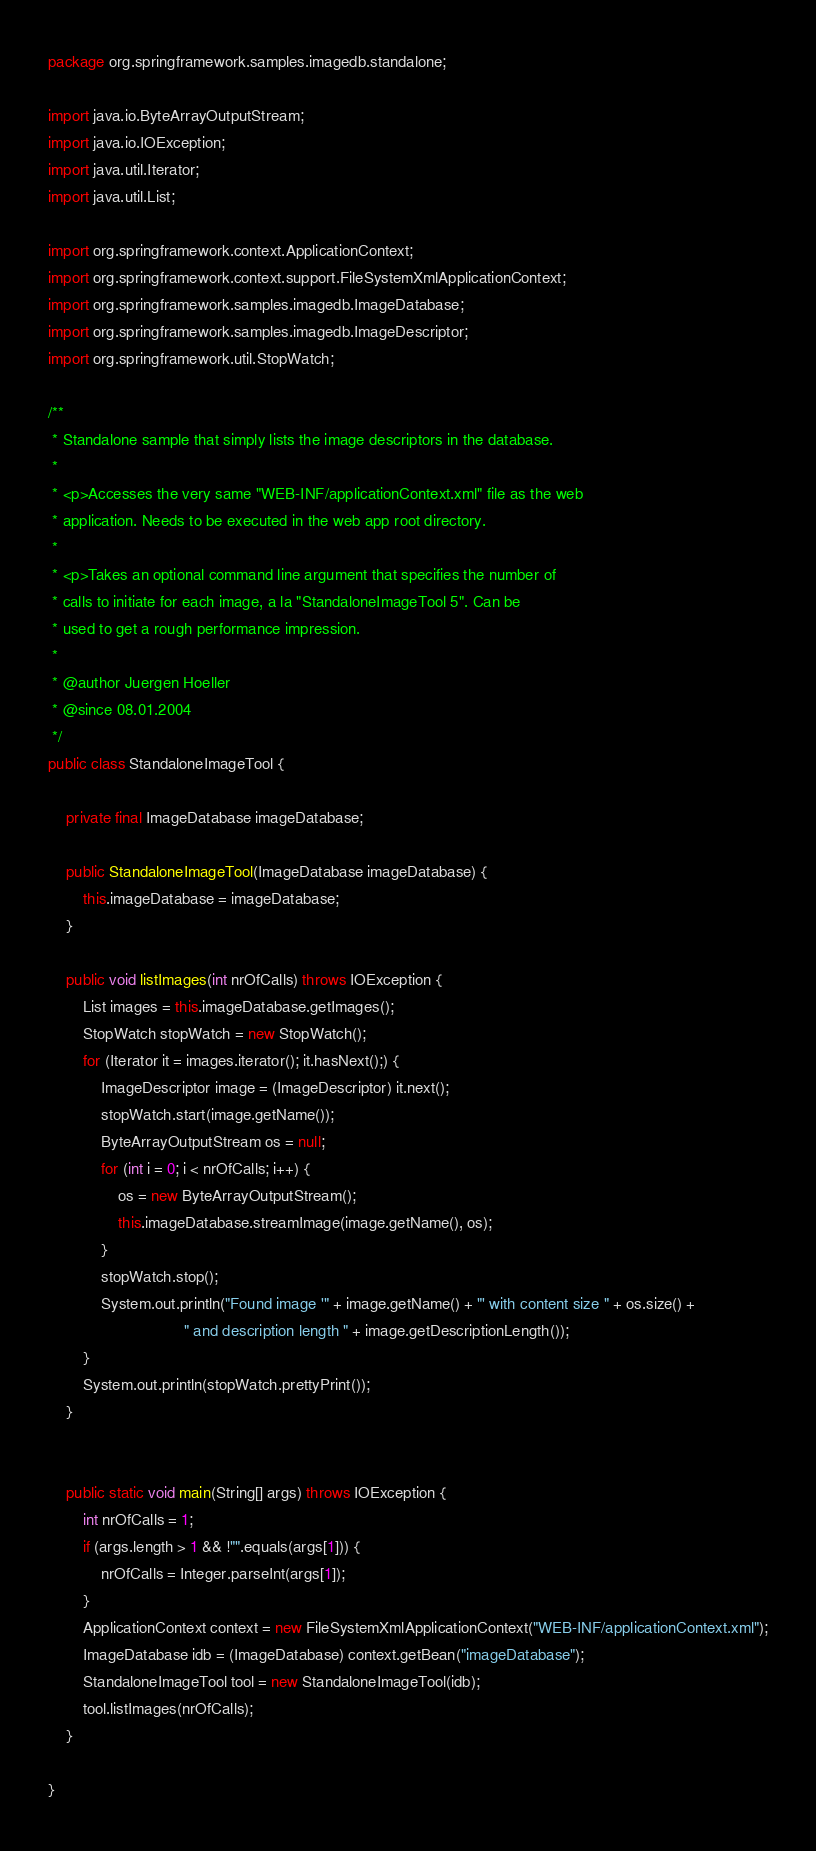<code> <loc_0><loc_0><loc_500><loc_500><_Java_>package org.springframework.samples.imagedb.standalone;

import java.io.ByteArrayOutputStream;
import java.io.IOException;
import java.util.Iterator;
import java.util.List;

import org.springframework.context.ApplicationContext;
import org.springframework.context.support.FileSystemXmlApplicationContext;
import org.springframework.samples.imagedb.ImageDatabase;
import org.springframework.samples.imagedb.ImageDescriptor;
import org.springframework.util.StopWatch;

/**
 * Standalone sample that simply lists the image descriptors in the database.
 *
 * <p>Accesses the very same "WEB-INF/applicationContext.xml" file as the web
 * application. Needs to be executed in the web app root directory.
 *
 * <p>Takes an optional command line argument that specifies the number of
 * calls to initiate for each image, a la "StandaloneImageTool 5". Can be
 * used to get a rough performance impression.
 *
 * @author Juergen Hoeller
 * @since 08.01.2004
 */
public class StandaloneImageTool {

	private final ImageDatabase imageDatabase;

	public StandaloneImageTool(ImageDatabase imageDatabase) {
		this.imageDatabase = imageDatabase;
	}

	public void listImages(int nrOfCalls) throws IOException {
		List images = this.imageDatabase.getImages();
		StopWatch stopWatch = new StopWatch();
		for (Iterator it = images.iterator(); it.hasNext();) {
			ImageDescriptor image = (ImageDescriptor) it.next();
			stopWatch.start(image.getName());
			ByteArrayOutputStream os = null;
			for (int i = 0; i < nrOfCalls; i++) {
				os = new ByteArrayOutputStream();
				this.imageDatabase.streamImage(image.getName(), os);
			}
			stopWatch.stop();
			System.out.println("Found image '" + image.getName() + "' with content size " + os.size() +
			                   " and description length " + image.getDescriptionLength());
		}
		System.out.println(stopWatch.prettyPrint());
	}


	public static void main(String[] args) throws IOException {
		int nrOfCalls = 1;
		if (args.length > 1 && !"".equals(args[1])) {
			nrOfCalls = Integer.parseInt(args[1]);
		}
		ApplicationContext context = new FileSystemXmlApplicationContext("WEB-INF/applicationContext.xml");
		ImageDatabase idb = (ImageDatabase) context.getBean("imageDatabase");
		StandaloneImageTool tool = new StandaloneImageTool(idb);
		tool.listImages(nrOfCalls);
	}

}
</code> 